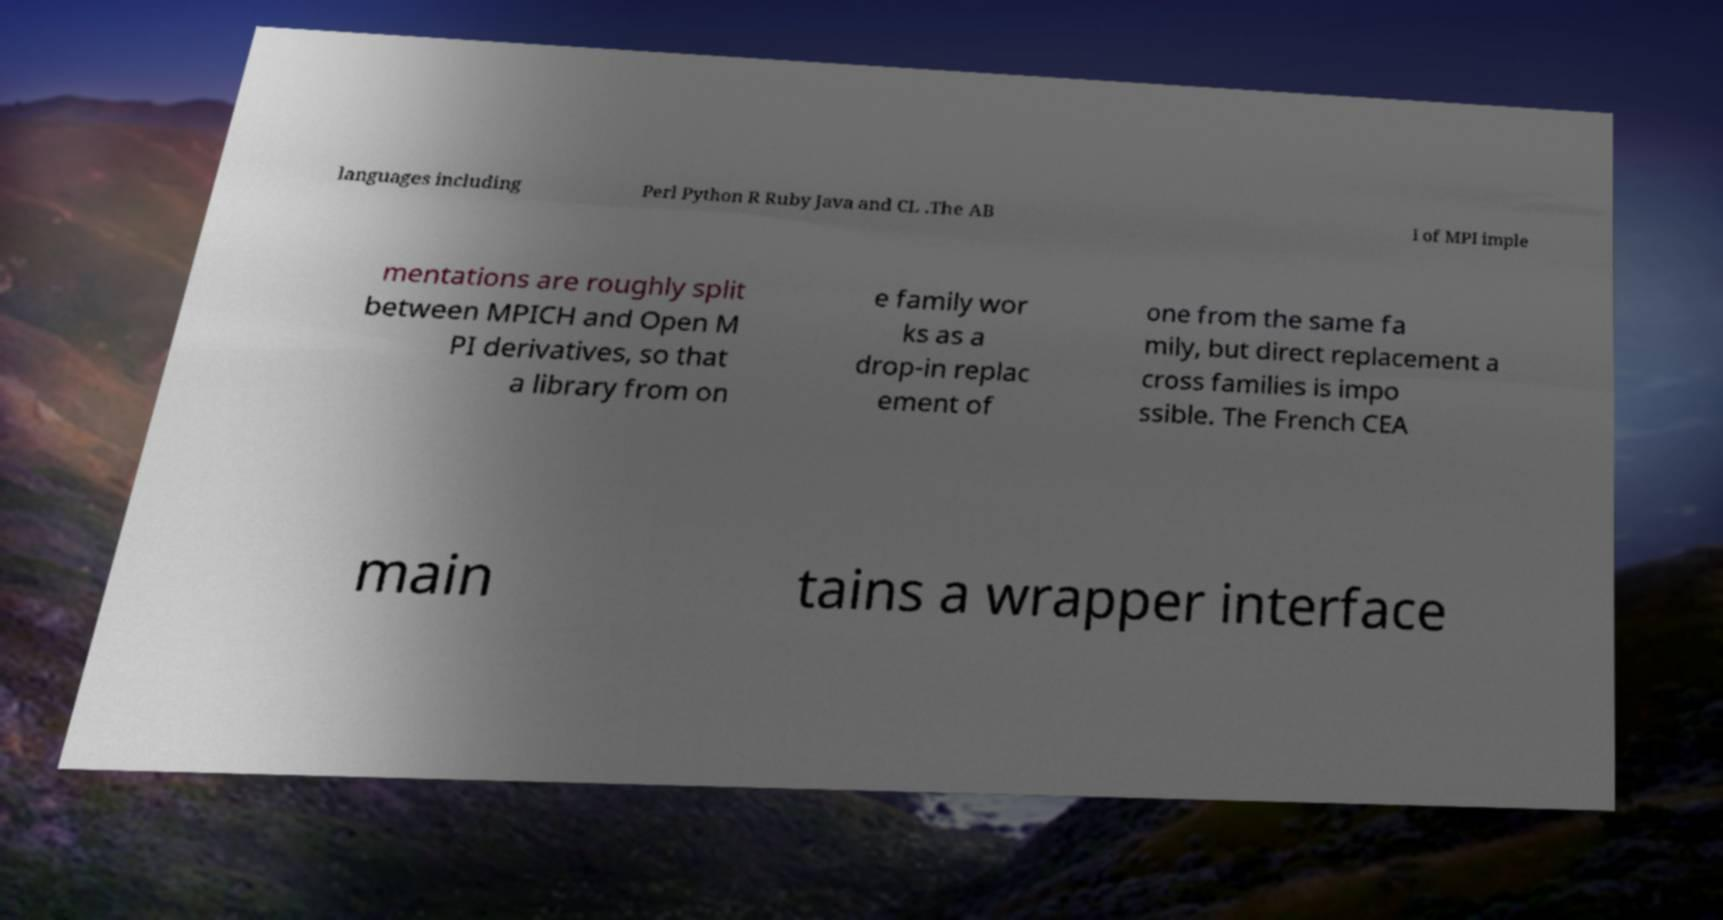Can you read and provide the text displayed in the image?This photo seems to have some interesting text. Can you extract and type it out for me? languages including Perl Python R Ruby Java and CL .The AB I of MPI imple mentations are roughly split between MPICH and Open M PI derivatives, so that a library from on e family wor ks as a drop-in replac ement of one from the same fa mily, but direct replacement a cross families is impo ssible. The French CEA main tains a wrapper interface 